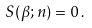Convert formula to latex. <formula><loc_0><loc_0><loc_500><loc_500>S ( \beta ; n ) = 0 \, .</formula> 